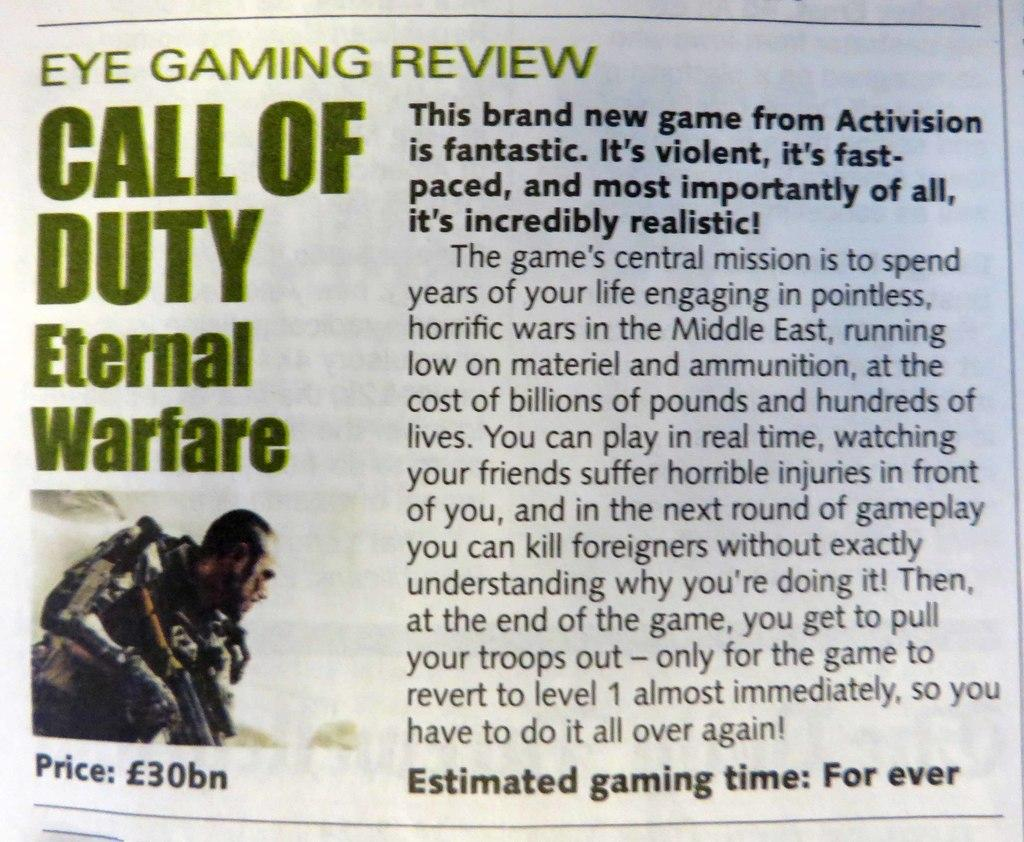What type of content is present in the image? There is an article and a picture in the image. Can you describe the article in the image? Unfortunately, the details of the article cannot be determined from the image alone. What is the subject of the picture in the image? The subject of the picture cannot be determined from the provided facts. How many dolls are sitting on the bubble in the image? There are no dolls or bubbles present in the image. What color is the toe on the doll in the image? There is no doll or toe present in the image. 